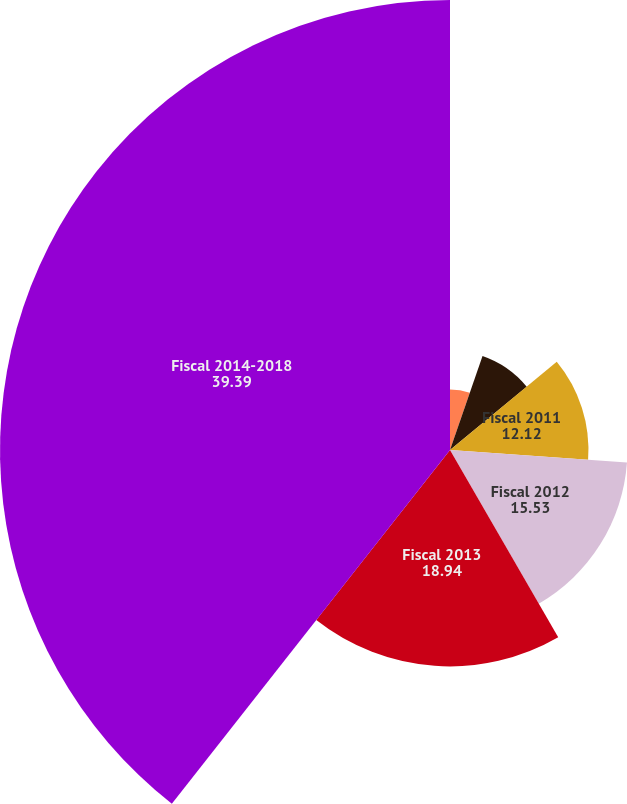Convert chart. <chart><loc_0><loc_0><loc_500><loc_500><pie_chart><fcel>Fiscal 2009<fcel>Fiscal 2010<fcel>Fiscal 2011<fcel>Fiscal 2012<fcel>Fiscal 2013<fcel>Fiscal 2014-2018<nl><fcel>5.3%<fcel>8.71%<fcel>12.12%<fcel>15.53%<fcel>18.94%<fcel>39.39%<nl></chart> 